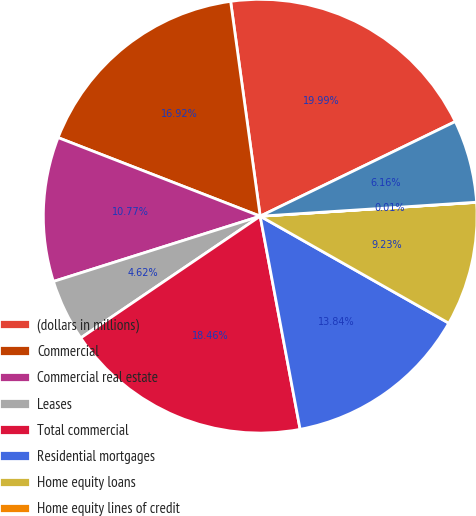<chart> <loc_0><loc_0><loc_500><loc_500><pie_chart><fcel>(dollars in millions)<fcel>Commercial<fcel>Commercial real estate<fcel>Leases<fcel>Total commercial<fcel>Residential mortgages<fcel>Home equity loans<fcel>Home equity lines of credit<fcel>Home equity loans serviced by<nl><fcel>19.99%<fcel>16.92%<fcel>10.77%<fcel>4.62%<fcel>18.46%<fcel>13.84%<fcel>9.23%<fcel>0.01%<fcel>6.16%<nl></chart> 